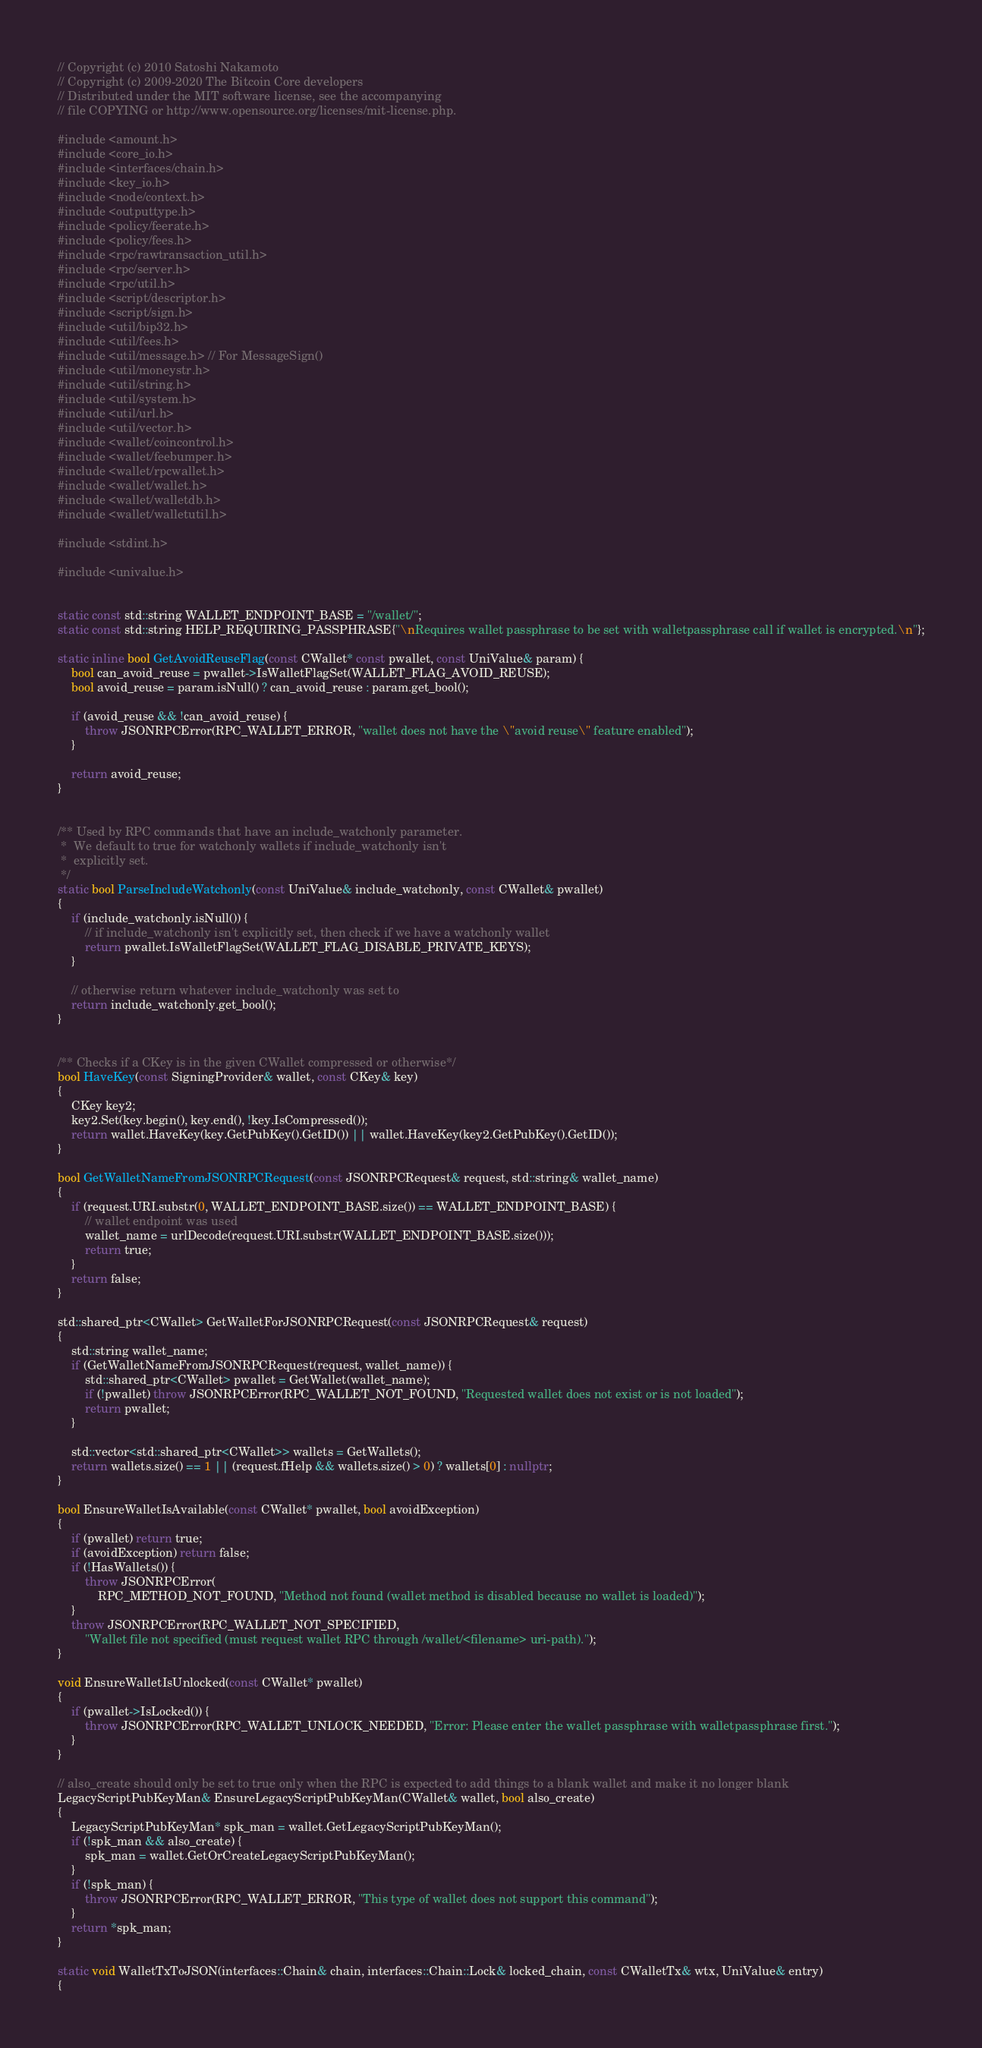<code> <loc_0><loc_0><loc_500><loc_500><_C++_>// Copyright (c) 2010 Satoshi Nakamoto
// Copyright (c) 2009-2020 The Bitcoin Core developers
// Distributed under the MIT software license, see the accompanying
// file COPYING or http://www.opensource.org/licenses/mit-license.php.

#include <amount.h>
#include <core_io.h>
#include <interfaces/chain.h>
#include <key_io.h>
#include <node/context.h>
#include <outputtype.h>
#include <policy/feerate.h>
#include <policy/fees.h>
#include <rpc/rawtransaction_util.h>
#include <rpc/server.h>
#include <rpc/util.h>
#include <script/descriptor.h>
#include <script/sign.h>
#include <util/bip32.h>
#include <util/fees.h>
#include <util/message.h> // For MessageSign()
#include <util/moneystr.h>
#include <util/string.h>
#include <util/system.h>
#include <util/url.h>
#include <util/vector.h>
#include <wallet/coincontrol.h>
#include <wallet/feebumper.h>
#include <wallet/rpcwallet.h>
#include <wallet/wallet.h>
#include <wallet/walletdb.h>
#include <wallet/walletutil.h>

#include <stdint.h>

#include <univalue.h>


static const std::string WALLET_ENDPOINT_BASE = "/wallet/";
static const std::string HELP_REQUIRING_PASSPHRASE{"\nRequires wallet passphrase to be set with walletpassphrase call if wallet is encrypted.\n"};

static inline bool GetAvoidReuseFlag(const CWallet* const pwallet, const UniValue& param) {
    bool can_avoid_reuse = pwallet->IsWalletFlagSet(WALLET_FLAG_AVOID_REUSE);
    bool avoid_reuse = param.isNull() ? can_avoid_reuse : param.get_bool();

    if (avoid_reuse && !can_avoid_reuse) {
        throw JSONRPCError(RPC_WALLET_ERROR, "wallet does not have the \"avoid reuse\" feature enabled");
    }

    return avoid_reuse;
}


/** Used by RPC commands that have an include_watchonly parameter.
 *  We default to true for watchonly wallets if include_watchonly isn't
 *  explicitly set.
 */
static bool ParseIncludeWatchonly(const UniValue& include_watchonly, const CWallet& pwallet)
{
    if (include_watchonly.isNull()) {
        // if include_watchonly isn't explicitly set, then check if we have a watchonly wallet
        return pwallet.IsWalletFlagSet(WALLET_FLAG_DISABLE_PRIVATE_KEYS);
    }

    // otherwise return whatever include_watchonly was set to
    return include_watchonly.get_bool();
}


/** Checks if a CKey is in the given CWallet compressed or otherwise*/
bool HaveKey(const SigningProvider& wallet, const CKey& key)
{
    CKey key2;
    key2.Set(key.begin(), key.end(), !key.IsCompressed());
    return wallet.HaveKey(key.GetPubKey().GetID()) || wallet.HaveKey(key2.GetPubKey().GetID());
}

bool GetWalletNameFromJSONRPCRequest(const JSONRPCRequest& request, std::string& wallet_name)
{
    if (request.URI.substr(0, WALLET_ENDPOINT_BASE.size()) == WALLET_ENDPOINT_BASE) {
        // wallet endpoint was used
        wallet_name = urlDecode(request.URI.substr(WALLET_ENDPOINT_BASE.size()));
        return true;
    }
    return false;
}

std::shared_ptr<CWallet> GetWalletForJSONRPCRequest(const JSONRPCRequest& request)
{
    std::string wallet_name;
    if (GetWalletNameFromJSONRPCRequest(request, wallet_name)) {
        std::shared_ptr<CWallet> pwallet = GetWallet(wallet_name);
        if (!pwallet) throw JSONRPCError(RPC_WALLET_NOT_FOUND, "Requested wallet does not exist or is not loaded");
        return pwallet;
    }

    std::vector<std::shared_ptr<CWallet>> wallets = GetWallets();
    return wallets.size() == 1 || (request.fHelp && wallets.size() > 0) ? wallets[0] : nullptr;
}

bool EnsureWalletIsAvailable(const CWallet* pwallet, bool avoidException)
{
    if (pwallet) return true;
    if (avoidException) return false;
    if (!HasWallets()) {
        throw JSONRPCError(
            RPC_METHOD_NOT_FOUND, "Method not found (wallet method is disabled because no wallet is loaded)");
    }
    throw JSONRPCError(RPC_WALLET_NOT_SPECIFIED,
        "Wallet file not specified (must request wallet RPC through /wallet/<filename> uri-path).");
}

void EnsureWalletIsUnlocked(const CWallet* pwallet)
{
    if (pwallet->IsLocked()) {
        throw JSONRPCError(RPC_WALLET_UNLOCK_NEEDED, "Error: Please enter the wallet passphrase with walletpassphrase first.");
    }
}

// also_create should only be set to true only when the RPC is expected to add things to a blank wallet and make it no longer blank
LegacyScriptPubKeyMan& EnsureLegacyScriptPubKeyMan(CWallet& wallet, bool also_create)
{
    LegacyScriptPubKeyMan* spk_man = wallet.GetLegacyScriptPubKeyMan();
    if (!spk_man && also_create) {
        spk_man = wallet.GetOrCreateLegacyScriptPubKeyMan();
    }
    if (!spk_man) {
        throw JSONRPCError(RPC_WALLET_ERROR, "This type of wallet does not support this command");
    }
    return *spk_man;
}

static void WalletTxToJSON(interfaces::Chain& chain, interfaces::Chain::Lock& locked_chain, const CWalletTx& wtx, UniValue& entry)
{</code> 